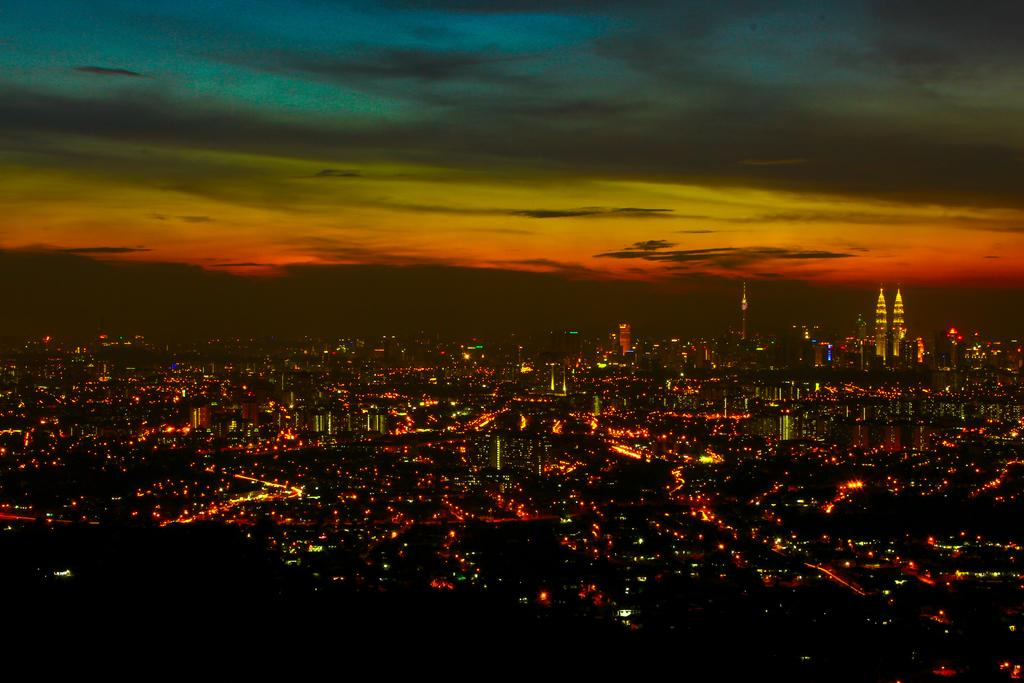What type of structures are present in the image? There are many buildings in the image. What can be seen illuminating the scene from left to right? Colorful lights are visible from left to right in the image. How would you describe the sky in the image? The sky is cloudy in the image. What type of dress is being worn by the coil in the image? There is no coil or dress present in the image. 